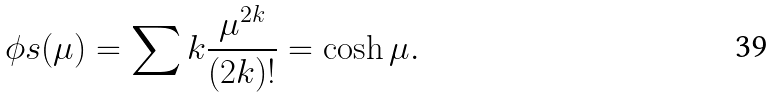Convert formula to latex. <formula><loc_0><loc_0><loc_500><loc_500>\phi s ( \mu ) = \sum k \frac { \mu ^ { 2 k } } { ( 2 k ) ! } = \cosh \mu .</formula> 